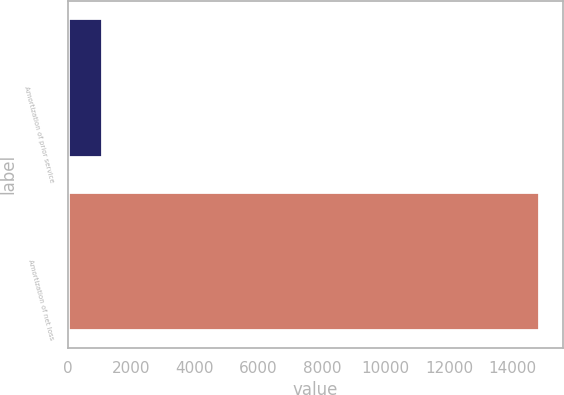<chart> <loc_0><loc_0><loc_500><loc_500><bar_chart><fcel>Amortization of prior service<fcel>Amortization of net loss<nl><fcel>1070<fcel>14829<nl></chart> 